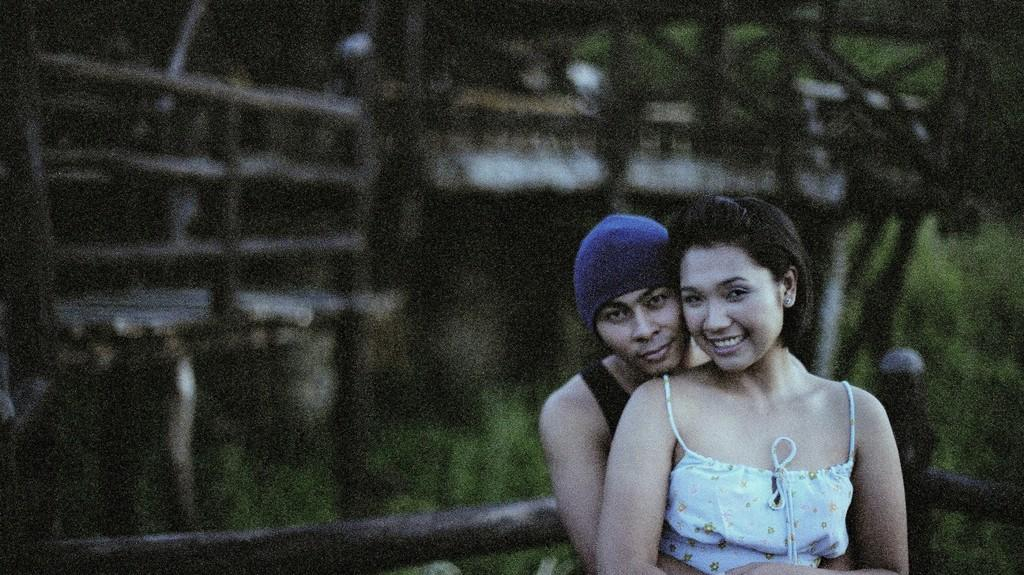How many people are present in the image? There are two people, a man and a woman, present in the image. What are the man and woman doing in the image? The man and woman are holding each other in the image. What can be seen in the background of the image? There are trees visible in the background of the image. What is the source of the wealth depicted in the image? There is no depiction of wealth in the image; it features a man and a woman holding each other with trees in the background. 